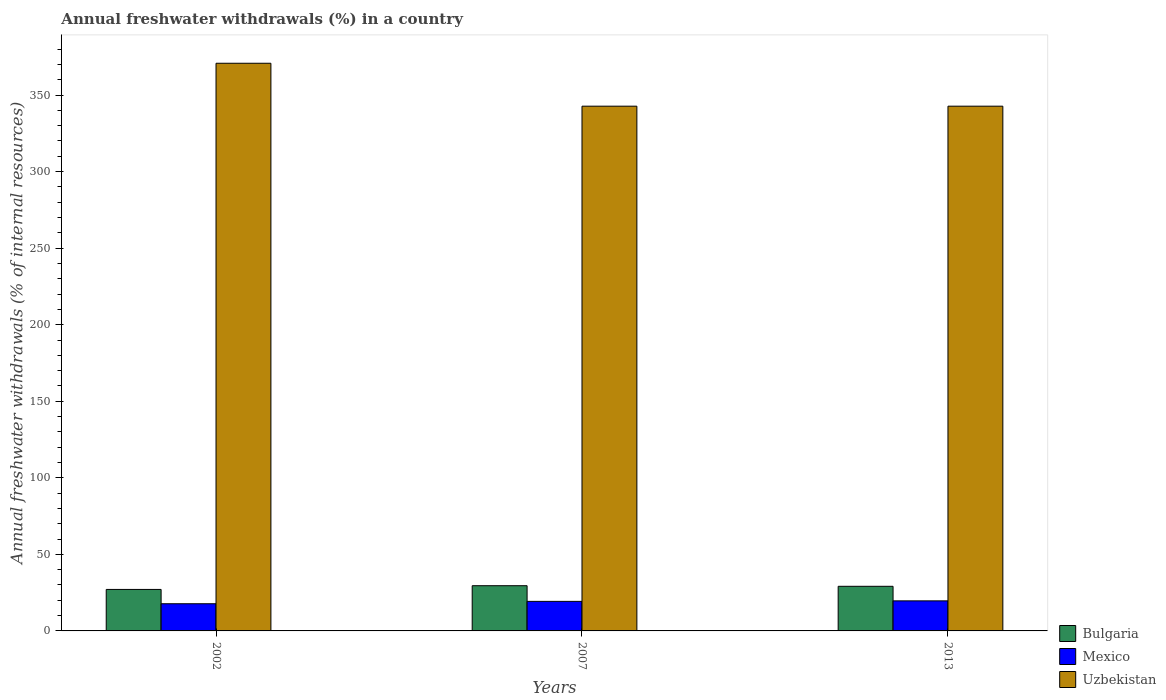How many groups of bars are there?
Ensure brevity in your answer.  3. Are the number of bars on each tick of the X-axis equal?
Make the answer very short. Yes. How many bars are there on the 3rd tick from the right?
Your answer should be compact. 3. What is the percentage of annual freshwater withdrawals in Mexico in 2002?
Provide a succinct answer. 17.75. Across all years, what is the maximum percentage of annual freshwater withdrawals in Bulgaria?
Make the answer very short. 29.53. Across all years, what is the minimum percentage of annual freshwater withdrawals in Bulgaria?
Provide a succinct answer. 27.1. In which year was the percentage of annual freshwater withdrawals in Bulgaria maximum?
Your answer should be very brief. 2007. What is the total percentage of annual freshwater withdrawals in Uzbekistan in the graph?
Offer a terse response. 1056.18. What is the difference between the percentage of annual freshwater withdrawals in Mexico in 2002 and that in 2007?
Provide a succinct answer. -1.55. What is the difference between the percentage of annual freshwater withdrawals in Mexico in 2002 and the percentage of annual freshwater withdrawals in Uzbekistan in 2013?
Provide a succinct answer. -324.97. What is the average percentage of annual freshwater withdrawals in Bulgaria per year?
Your answer should be very brief. 28.59. In the year 2013, what is the difference between the percentage of annual freshwater withdrawals in Bulgaria and percentage of annual freshwater withdrawals in Uzbekistan?
Make the answer very short. -313.58. What is the ratio of the percentage of annual freshwater withdrawals in Bulgaria in 2002 to that in 2013?
Give a very brief answer. 0.93. Is the difference between the percentage of annual freshwater withdrawals in Bulgaria in 2007 and 2013 greater than the difference between the percentage of annual freshwater withdrawals in Uzbekistan in 2007 and 2013?
Ensure brevity in your answer.  Yes. What is the difference between the highest and the second highest percentage of annual freshwater withdrawals in Bulgaria?
Your answer should be very brief. 0.39. What is the difference between the highest and the lowest percentage of annual freshwater withdrawals in Bulgaria?
Provide a succinct answer. 2.43. What does the 3rd bar from the left in 2013 represents?
Your answer should be compact. Uzbekistan. How many bars are there?
Your answer should be compact. 9. Are all the bars in the graph horizontal?
Provide a short and direct response. No. What is the difference between two consecutive major ticks on the Y-axis?
Ensure brevity in your answer.  50. Are the values on the major ticks of Y-axis written in scientific E-notation?
Give a very brief answer. No. Does the graph contain grids?
Offer a terse response. No. Where does the legend appear in the graph?
Offer a very short reply. Bottom right. What is the title of the graph?
Offer a very short reply. Annual freshwater withdrawals (%) in a country. What is the label or title of the X-axis?
Make the answer very short. Years. What is the label or title of the Y-axis?
Ensure brevity in your answer.  Annual freshwater withdrawals (% of internal resources). What is the Annual freshwater withdrawals (% of internal resources) in Bulgaria in 2002?
Your answer should be compact. 27.1. What is the Annual freshwater withdrawals (% of internal resources) in Mexico in 2002?
Provide a short and direct response. 17.75. What is the Annual freshwater withdrawals (% of internal resources) in Uzbekistan in 2002?
Make the answer very short. 370.75. What is the Annual freshwater withdrawals (% of internal resources) in Bulgaria in 2007?
Ensure brevity in your answer.  29.53. What is the Annual freshwater withdrawals (% of internal resources) in Mexico in 2007?
Your response must be concise. 19.3. What is the Annual freshwater withdrawals (% of internal resources) of Uzbekistan in 2007?
Your answer should be very brief. 342.72. What is the Annual freshwater withdrawals (% of internal resources) in Bulgaria in 2013?
Your response must be concise. 29.14. What is the Annual freshwater withdrawals (% of internal resources) in Mexico in 2013?
Keep it short and to the point. 19.63. What is the Annual freshwater withdrawals (% of internal resources) in Uzbekistan in 2013?
Ensure brevity in your answer.  342.72. Across all years, what is the maximum Annual freshwater withdrawals (% of internal resources) in Bulgaria?
Provide a short and direct response. 29.53. Across all years, what is the maximum Annual freshwater withdrawals (% of internal resources) of Mexico?
Offer a terse response. 19.63. Across all years, what is the maximum Annual freshwater withdrawals (% of internal resources) of Uzbekistan?
Offer a very short reply. 370.75. Across all years, what is the minimum Annual freshwater withdrawals (% of internal resources) in Bulgaria?
Give a very brief answer. 27.1. Across all years, what is the minimum Annual freshwater withdrawals (% of internal resources) of Mexico?
Ensure brevity in your answer.  17.75. Across all years, what is the minimum Annual freshwater withdrawals (% of internal resources) of Uzbekistan?
Make the answer very short. 342.72. What is the total Annual freshwater withdrawals (% of internal resources) of Bulgaria in the graph?
Keep it short and to the point. 85.76. What is the total Annual freshwater withdrawals (% of internal resources) in Mexico in the graph?
Provide a short and direct response. 56.69. What is the total Annual freshwater withdrawals (% of internal resources) in Uzbekistan in the graph?
Ensure brevity in your answer.  1056.18. What is the difference between the Annual freshwater withdrawals (% of internal resources) of Bulgaria in 2002 and that in 2007?
Keep it short and to the point. -2.43. What is the difference between the Annual freshwater withdrawals (% of internal resources) of Mexico in 2002 and that in 2007?
Offer a terse response. -1.55. What is the difference between the Annual freshwater withdrawals (% of internal resources) in Uzbekistan in 2002 and that in 2007?
Ensure brevity in your answer.  28.03. What is the difference between the Annual freshwater withdrawals (% of internal resources) in Bulgaria in 2002 and that in 2013?
Ensure brevity in your answer.  -2.04. What is the difference between the Annual freshwater withdrawals (% of internal resources) of Mexico in 2002 and that in 2013?
Your answer should be compact. -1.88. What is the difference between the Annual freshwater withdrawals (% of internal resources) in Uzbekistan in 2002 and that in 2013?
Make the answer very short. 28.03. What is the difference between the Annual freshwater withdrawals (% of internal resources) of Bulgaria in 2007 and that in 2013?
Your answer should be compact. 0.39. What is the difference between the Annual freshwater withdrawals (% of internal resources) in Mexico in 2007 and that in 2013?
Offer a terse response. -0.33. What is the difference between the Annual freshwater withdrawals (% of internal resources) of Bulgaria in 2002 and the Annual freshwater withdrawals (% of internal resources) of Mexico in 2007?
Offer a terse response. 7.79. What is the difference between the Annual freshwater withdrawals (% of internal resources) of Bulgaria in 2002 and the Annual freshwater withdrawals (% of internal resources) of Uzbekistan in 2007?
Your answer should be very brief. -315.62. What is the difference between the Annual freshwater withdrawals (% of internal resources) of Mexico in 2002 and the Annual freshwater withdrawals (% of internal resources) of Uzbekistan in 2007?
Make the answer very short. -324.97. What is the difference between the Annual freshwater withdrawals (% of internal resources) of Bulgaria in 2002 and the Annual freshwater withdrawals (% of internal resources) of Mexico in 2013?
Provide a short and direct response. 7.46. What is the difference between the Annual freshwater withdrawals (% of internal resources) of Bulgaria in 2002 and the Annual freshwater withdrawals (% of internal resources) of Uzbekistan in 2013?
Your answer should be very brief. -315.62. What is the difference between the Annual freshwater withdrawals (% of internal resources) in Mexico in 2002 and the Annual freshwater withdrawals (% of internal resources) in Uzbekistan in 2013?
Ensure brevity in your answer.  -324.97. What is the difference between the Annual freshwater withdrawals (% of internal resources) of Bulgaria in 2007 and the Annual freshwater withdrawals (% of internal resources) of Mexico in 2013?
Your answer should be compact. 9.9. What is the difference between the Annual freshwater withdrawals (% of internal resources) of Bulgaria in 2007 and the Annual freshwater withdrawals (% of internal resources) of Uzbekistan in 2013?
Provide a short and direct response. -313.19. What is the difference between the Annual freshwater withdrawals (% of internal resources) in Mexico in 2007 and the Annual freshwater withdrawals (% of internal resources) in Uzbekistan in 2013?
Offer a very short reply. -323.41. What is the average Annual freshwater withdrawals (% of internal resources) of Bulgaria per year?
Your response must be concise. 28.59. What is the average Annual freshwater withdrawals (% of internal resources) in Mexico per year?
Your answer should be very brief. 18.9. What is the average Annual freshwater withdrawals (% of internal resources) in Uzbekistan per year?
Your answer should be compact. 352.06. In the year 2002, what is the difference between the Annual freshwater withdrawals (% of internal resources) of Bulgaria and Annual freshwater withdrawals (% of internal resources) of Mexico?
Offer a terse response. 9.34. In the year 2002, what is the difference between the Annual freshwater withdrawals (% of internal resources) of Bulgaria and Annual freshwater withdrawals (% of internal resources) of Uzbekistan?
Give a very brief answer. -343.65. In the year 2002, what is the difference between the Annual freshwater withdrawals (% of internal resources) in Mexico and Annual freshwater withdrawals (% of internal resources) in Uzbekistan?
Your answer should be compact. -353. In the year 2007, what is the difference between the Annual freshwater withdrawals (% of internal resources) of Bulgaria and Annual freshwater withdrawals (% of internal resources) of Mexico?
Ensure brevity in your answer.  10.23. In the year 2007, what is the difference between the Annual freshwater withdrawals (% of internal resources) in Bulgaria and Annual freshwater withdrawals (% of internal resources) in Uzbekistan?
Provide a short and direct response. -313.19. In the year 2007, what is the difference between the Annual freshwater withdrawals (% of internal resources) in Mexico and Annual freshwater withdrawals (% of internal resources) in Uzbekistan?
Your response must be concise. -323.41. In the year 2013, what is the difference between the Annual freshwater withdrawals (% of internal resources) in Bulgaria and Annual freshwater withdrawals (% of internal resources) in Mexico?
Give a very brief answer. 9.5. In the year 2013, what is the difference between the Annual freshwater withdrawals (% of internal resources) in Bulgaria and Annual freshwater withdrawals (% of internal resources) in Uzbekistan?
Your answer should be compact. -313.58. In the year 2013, what is the difference between the Annual freshwater withdrawals (% of internal resources) of Mexico and Annual freshwater withdrawals (% of internal resources) of Uzbekistan?
Ensure brevity in your answer.  -323.08. What is the ratio of the Annual freshwater withdrawals (% of internal resources) in Bulgaria in 2002 to that in 2007?
Provide a short and direct response. 0.92. What is the ratio of the Annual freshwater withdrawals (% of internal resources) of Mexico in 2002 to that in 2007?
Offer a terse response. 0.92. What is the ratio of the Annual freshwater withdrawals (% of internal resources) in Uzbekistan in 2002 to that in 2007?
Your answer should be compact. 1.08. What is the ratio of the Annual freshwater withdrawals (% of internal resources) of Bulgaria in 2002 to that in 2013?
Offer a terse response. 0.93. What is the ratio of the Annual freshwater withdrawals (% of internal resources) in Mexico in 2002 to that in 2013?
Ensure brevity in your answer.  0.9. What is the ratio of the Annual freshwater withdrawals (% of internal resources) of Uzbekistan in 2002 to that in 2013?
Make the answer very short. 1.08. What is the ratio of the Annual freshwater withdrawals (% of internal resources) in Bulgaria in 2007 to that in 2013?
Offer a very short reply. 1.01. What is the ratio of the Annual freshwater withdrawals (% of internal resources) of Mexico in 2007 to that in 2013?
Your answer should be very brief. 0.98. What is the difference between the highest and the second highest Annual freshwater withdrawals (% of internal resources) of Bulgaria?
Provide a succinct answer. 0.39. What is the difference between the highest and the second highest Annual freshwater withdrawals (% of internal resources) of Mexico?
Make the answer very short. 0.33. What is the difference between the highest and the second highest Annual freshwater withdrawals (% of internal resources) in Uzbekistan?
Offer a very short reply. 28.03. What is the difference between the highest and the lowest Annual freshwater withdrawals (% of internal resources) in Bulgaria?
Ensure brevity in your answer.  2.43. What is the difference between the highest and the lowest Annual freshwater withdrawals (% of internal resources) of Mexico?
Offer a terse response. 1.88. What is the difference between the highest and the lowest Annual freshwater withdrawals (% of internal resources) in Uzbekistan?
Offer a very short reply. 28.03. 